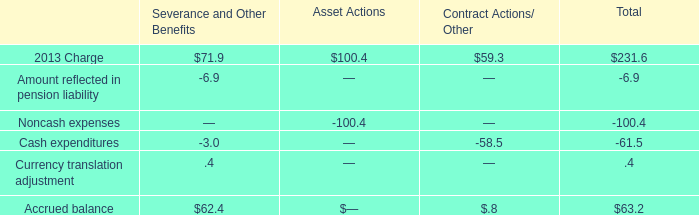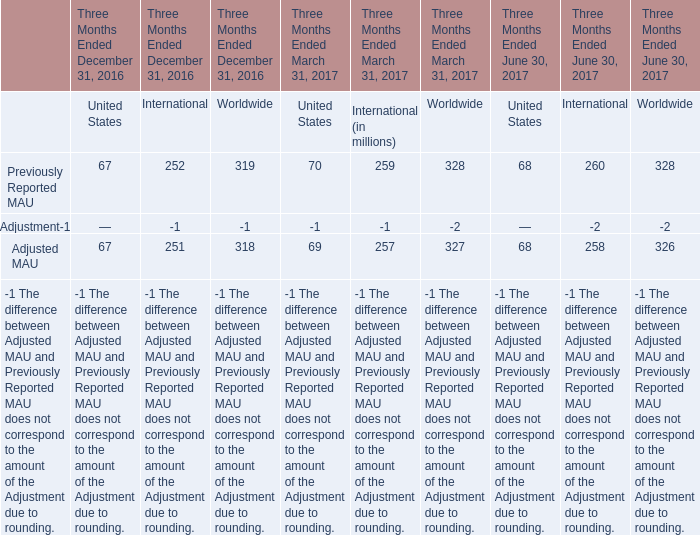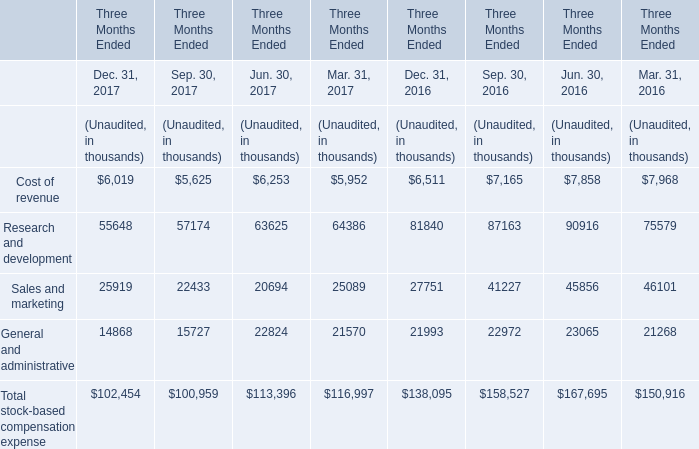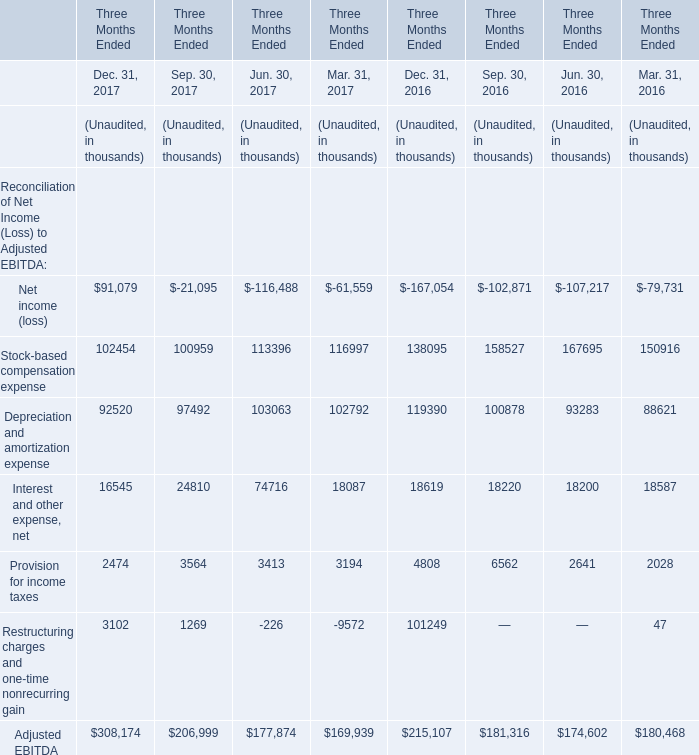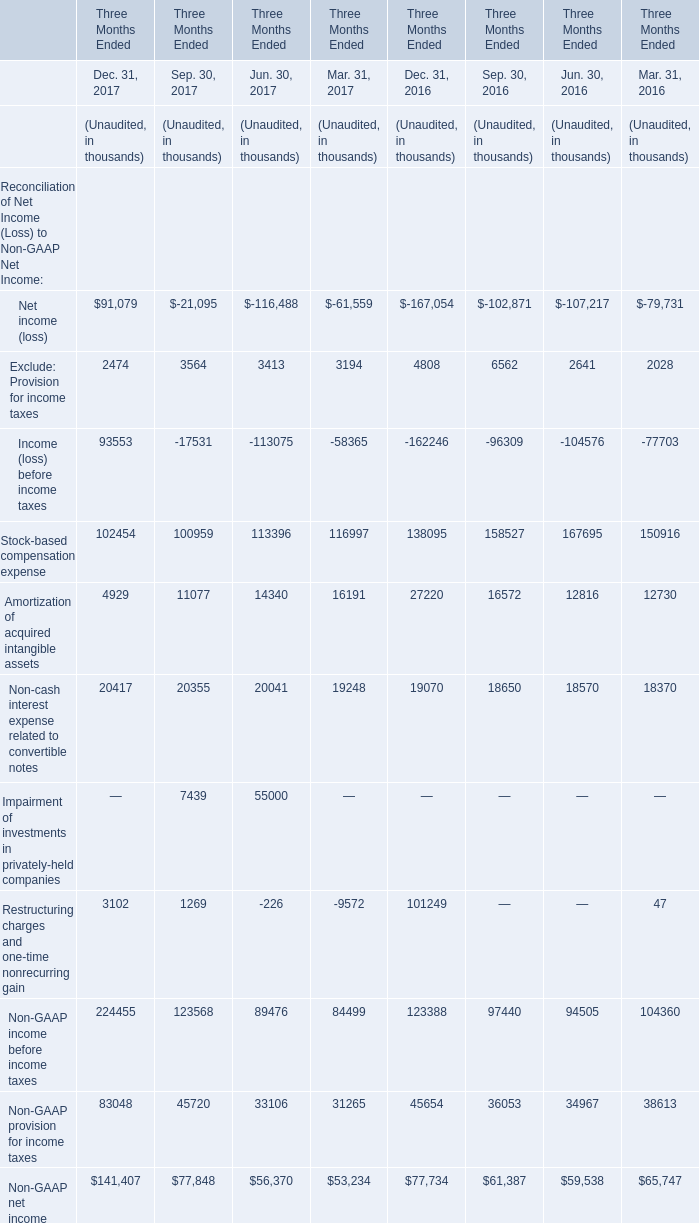What was the total amount of Dec. 31, 2017 in the range of 2000 and 4000 in 2017? (in thousand) 
Computations: (2474 + 3102)
Answer: 5576.0. 